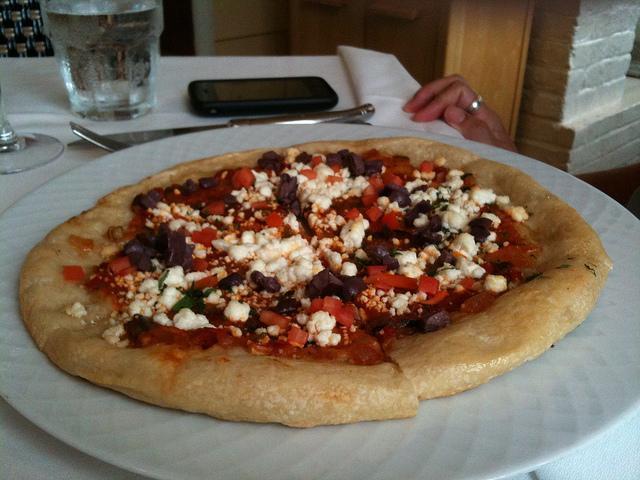How many pizzas are pictured?
Give a very brief answer. 1. How many wine glasses are there?
Give a very brief answer. 1. How many cell phones are in the photo?
Give a very brief answer. 1. 